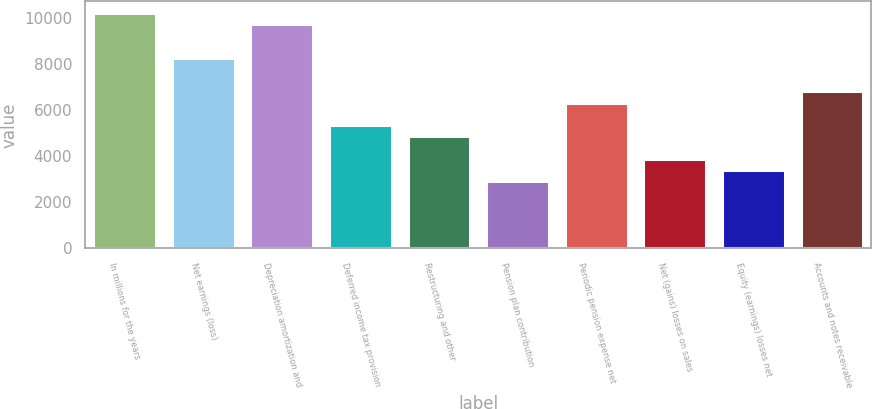<chart> <loc_0><loc_0><loc_500><loc_500><bar_chart><fcel>In millions for the years<fcel>Net earnings (loss)<fcel>Depreciation amortization and<fcel>Deferred income tax provision<fcel>Restructuring and other<fcel>Pension plan contribution<fcel>Periodic pension expense net<fcel>Net (gains) losses on sales<fcel>Equity (earnings) losses net<fcel>Accounts and notes receivable<nl><fcel>10195.2<fcel>8254.4<fcel>9710<fcel>5343.2<fcel>4858<fcel>2917.2<fcel>6313.6<fcel>3887.6<fcel>3402.4<fcel>6798.8<nl></chart> 